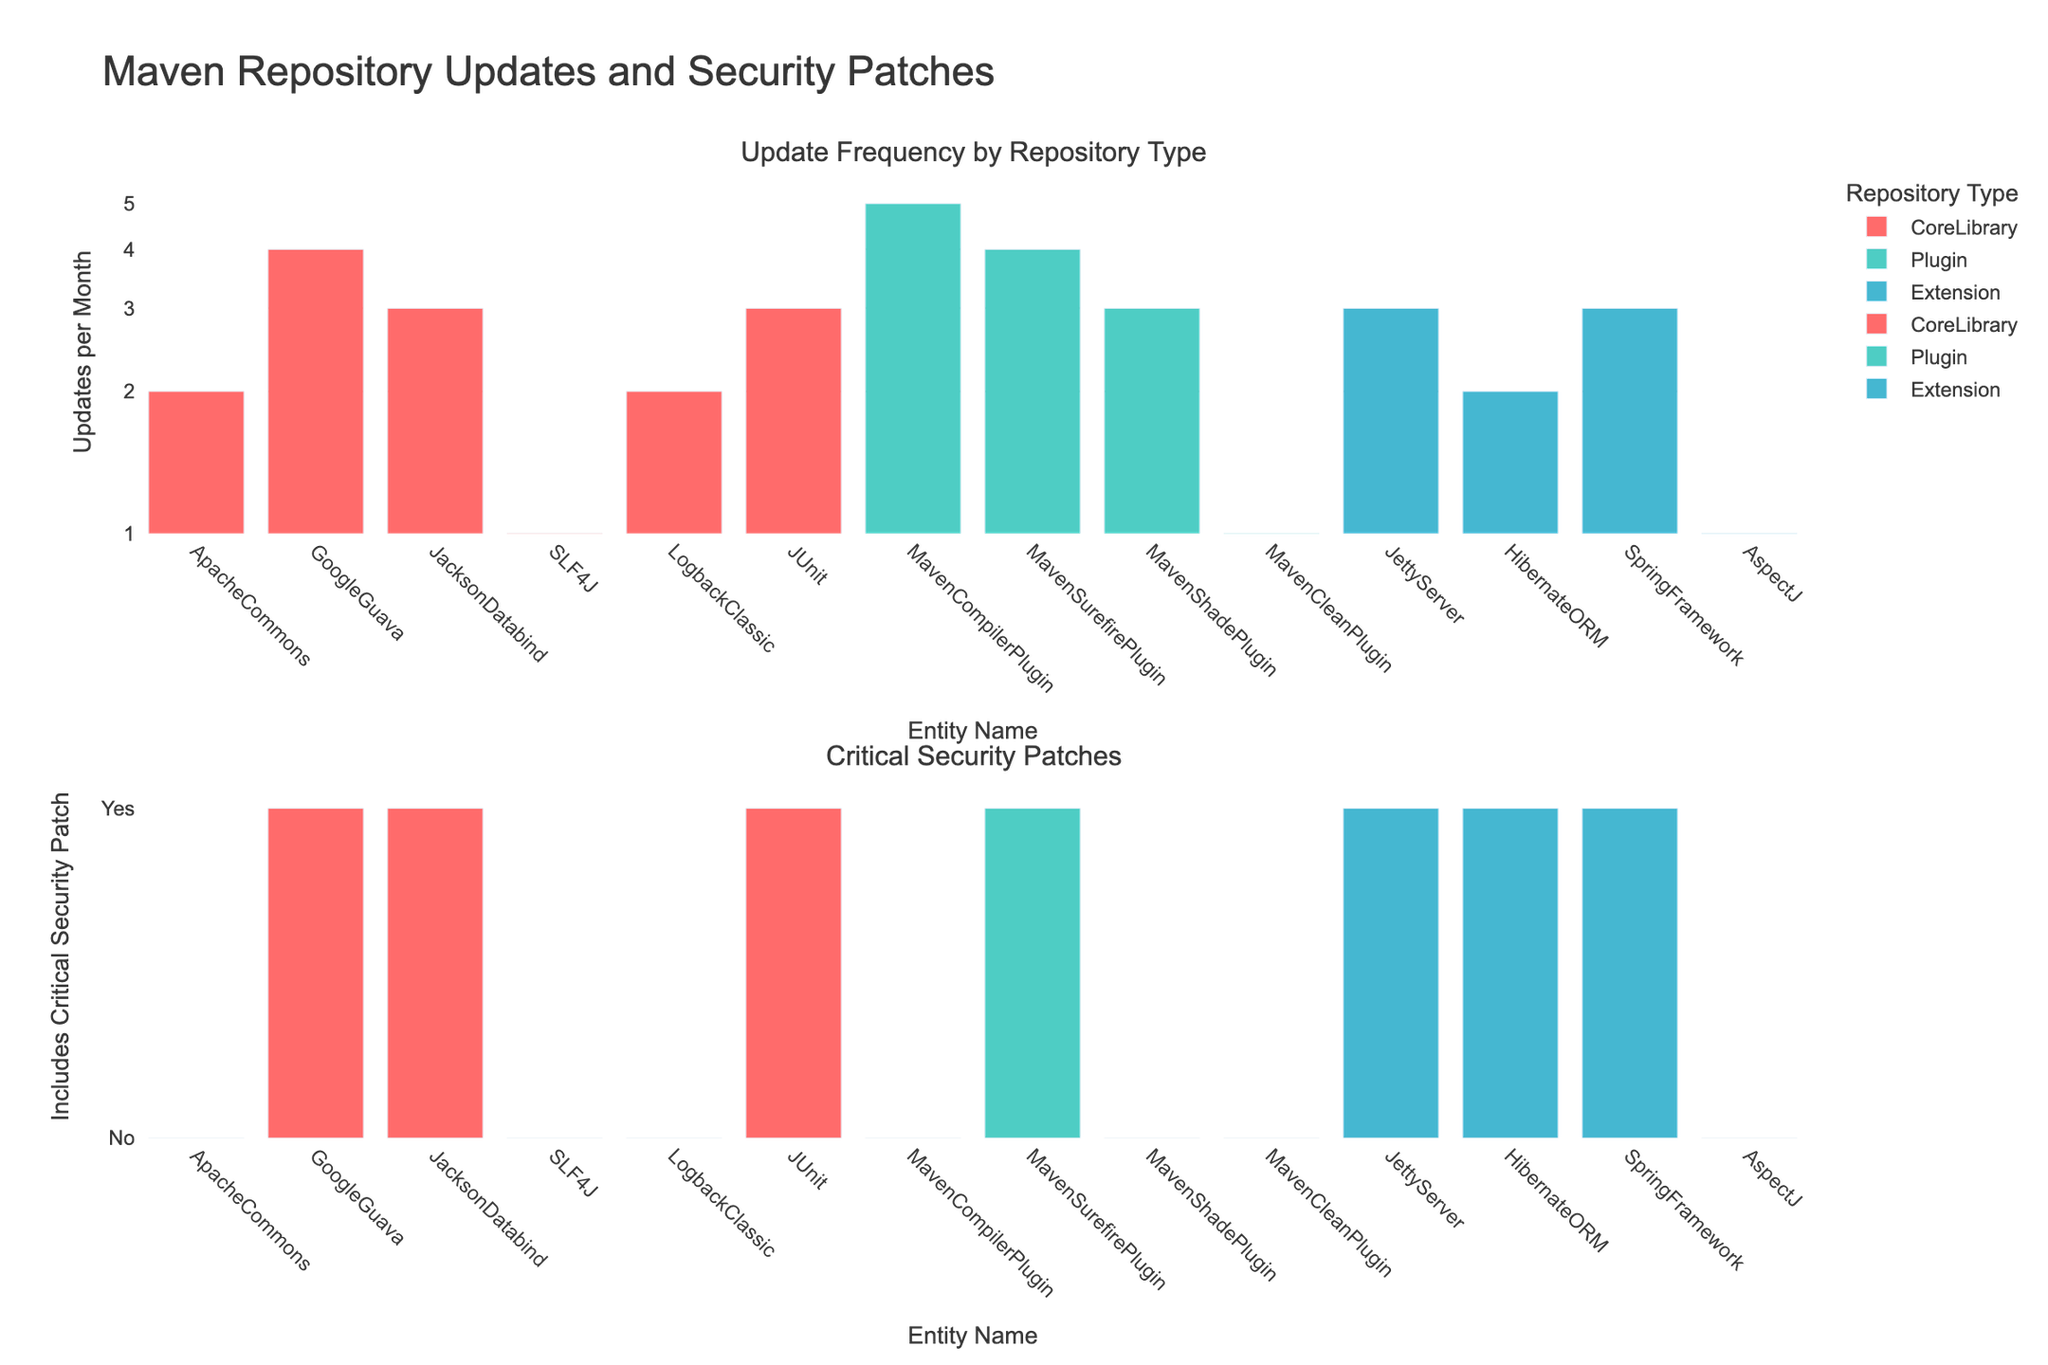Which repository type has the highest update frequency per month? The highest bar in the first subplot corresponds to the 'MavenCompilerPlugin' in the 'Plugin' repository type.
Answer: Plugin Which core library includes a critical security patch? From the second subplot, 'GoogleGuava', 'JacksonDatabind', and 'JUnit' in the CoreLibrary category have bars indicating a critical security patch.
Answer: GoogleGuava, JacksonDatabind, JUnit How many plugins include critical security patches? Counting the bars in the 'Plugin' category in the second subplot that are set to 'Yes' for security patches, we find there are two plugins: 'MavenSurefirePlugin' and 'MavenShadePlugin'.
Answer: 2 What is the update frequency per month for 'SpringFramework'? The bar for 'SpringFramework' in the first subplot shows it has 3 updates per month.
Answer: 3 What is the update frequency difference between 'SLF4J' and 'ApacheCommons'? 'SLF4J' has 1 update per month while 'ApacheCommons' has 2 updates per month. The difference is 2 - 1 = 1.
Answer: 1 Which extensions contain critical security patches? In the second subplot, the bars for 'JettyServer', 'HibernateORM', and 'SpringFramework' in the Extension category indicate the inclusion of security patches.
Answer: JettyServer, HibernateORM, SpringFramework Do any plugins have an update frequency of 5 per month? Yes, 'MavenCompilerPlugin' in the first subplot has an update frequency of 5 per month.
Answer: Yes Are there any entities with exactly one update per month? Both the 'SLF4J' in the CoreLibrary category and 'AspectJ' in the Extension category have bars indicating one update per month.
Answer: Yes Does 'LogbackClassic' in the CoreLibrary category include any critical security patches? The second subplot shows that 'LogbackClassic' in the CoreLibrary category does not have a bar indicating critical security patches, thus it does not include any.
Answer: No 